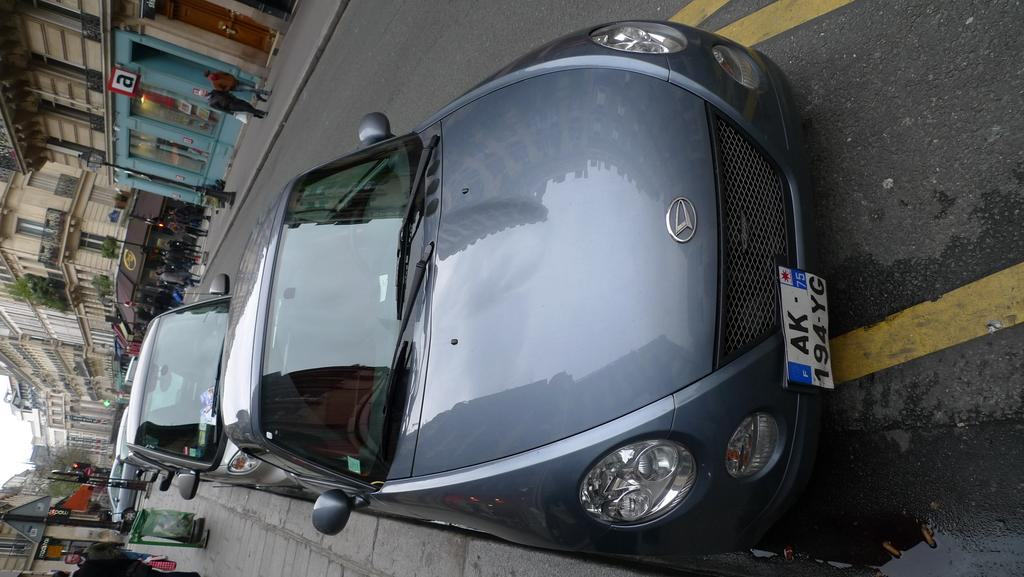<image>
Present a compact description of the photo's key features. A grey car with license plate AK194YG is parked on the side of the street. 